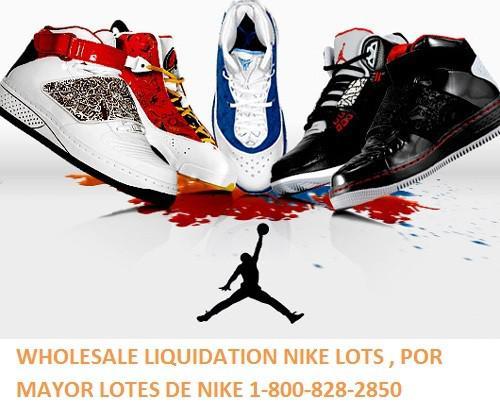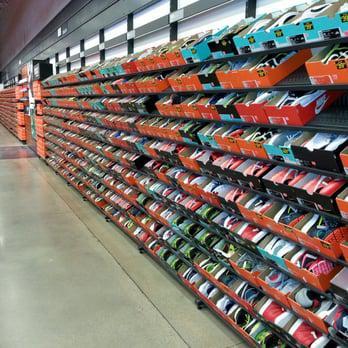The first image is the image on the left, the second image is the image on the right. For the images shown, is this caption "An image shows shoes lined up in rows in store displays." true? Answer yes or no. Yes. The first image is the image on the left, the second image is the image on the right. Given the left and right images, does the statement "At least one image has shoes that are not stacked in a random pile" hold true? Answer yes or no. No. 